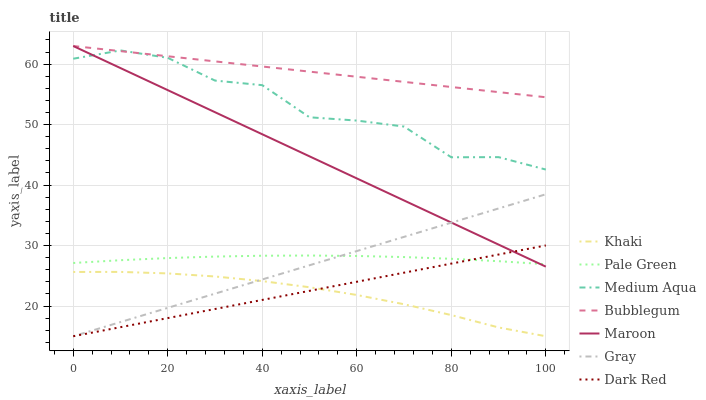Does Khaki have the minimum area under the curve?
Answer yes or no. Yes. Does Bubblegum have the maximum area under the curve?
Answer yes or no. Yes. Does Dark Red have the minimum area under the curve?
Answer yes or no. No. Does Dark Red have the maximum area under the curve?
Answer yes or no. No. Is Dark Red the smoothest?
Answer yes or no. Yes. Is Medium Aqua the roughest?
Answer yes or no. Yes. Is Khaki the smoothest?
Answer yes or no. No. Is Khaki the roughest?
Answer yes or no. No. Does Gray have the lowest value?
Answer yes or no. Yes. Does Maroon have the lowest value?
Answer yes or no. No. Does Bubblegum have the highest value?
Answer yes or no. Yes. Does Dark Red have the highest value?
Answer yes or no. No. Is Gray less than Bubblegum?
Answer yes or no. Yes. Is Pale Green greater than Khaki?
Answer yes or no. Yes. Does Gray intersect Maroon?
Answer yes or no. Yes. Is Gray less than Maroon?
Answer yes or no. No. Is Gray greater than Maroon?
Answer yes or no. No. Does Gray intersect Bubblegum?
Answer yes or no. No. 